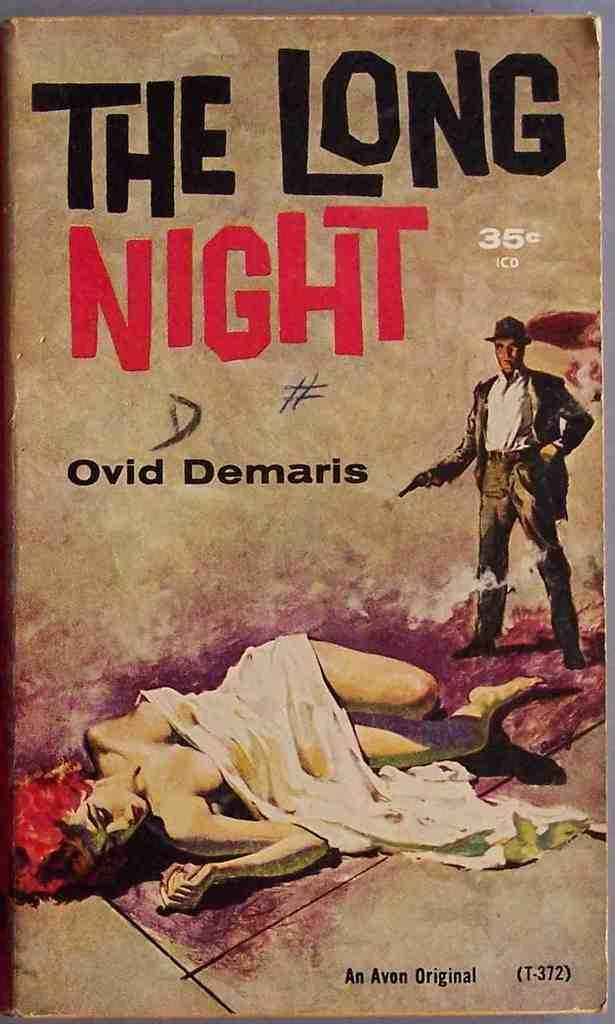<image>
Relay a brief, clear account of the picture shown. According to its cover, a 35 cent paperback novel is an Avon Original. 